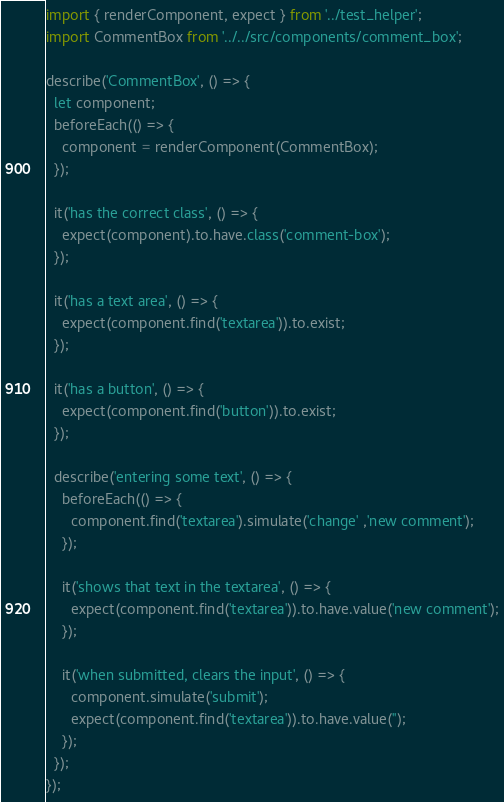Convert code to text. <code><loc_0><loc_0><loc_500><loc_500><_JavaScript_>import { renderComponent, expect } from '../test_helper';
import CommentBox from '../../src/components/comment_box';

describe('CommentBox', () => {
  let component;
  beforeEach(() => {
    component = renderComponent(CommentBox);
  });

  it('has the correct class', () => {
    expect(component).to.have.class('comment-box');
  });

  it('has a text area', () => {
    expect(component.find('textarea')).to.exist;
  });

  it('has a button', () => {
    expect(component.find('button')).to.exist;
  });

  describe('entering some text', () => {
    beforeEach(() => {
      component.find('textarea').simulate('change' ,'new comment');
    });

    it('shows that text in the textarea', () => {
      expect(component.find('textarea')).to.have.value('new comment');
    });
  
    it('when submitted, clears the input', () => {
      component.simulate('submit');
      expect(component.find('textarea')).to.have.value('');
    });
  });
});</code> 